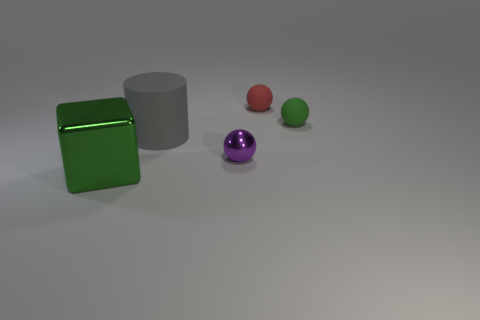Subtract all gray spheres. Subtract all purple blocks. How many spheres are left? 3 Add 5 small brown metallic spheres. How many objects exist? 10 Subtract all balls. How many objects are left? 2 Subtract all small purple balls. Subtract all gray rubber cylinders. How many objects are left? 3 Add 3 small metal spheres. How many small metal spheres are left? 4 Add 1 small cubes. How many small cubes exist? 1 Subtract 0 blue spheres. How many objects are left? 5 